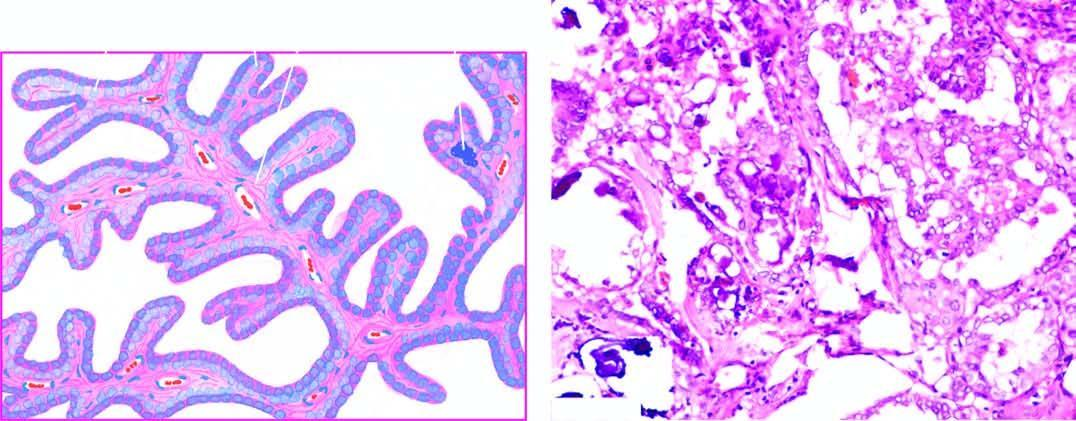what shows branching papillae having flbrovascular stalk covered by a single layer of cuboidal cells having ground-glass nuclei?
Answer the question using a single word or phrase. Microscopy 